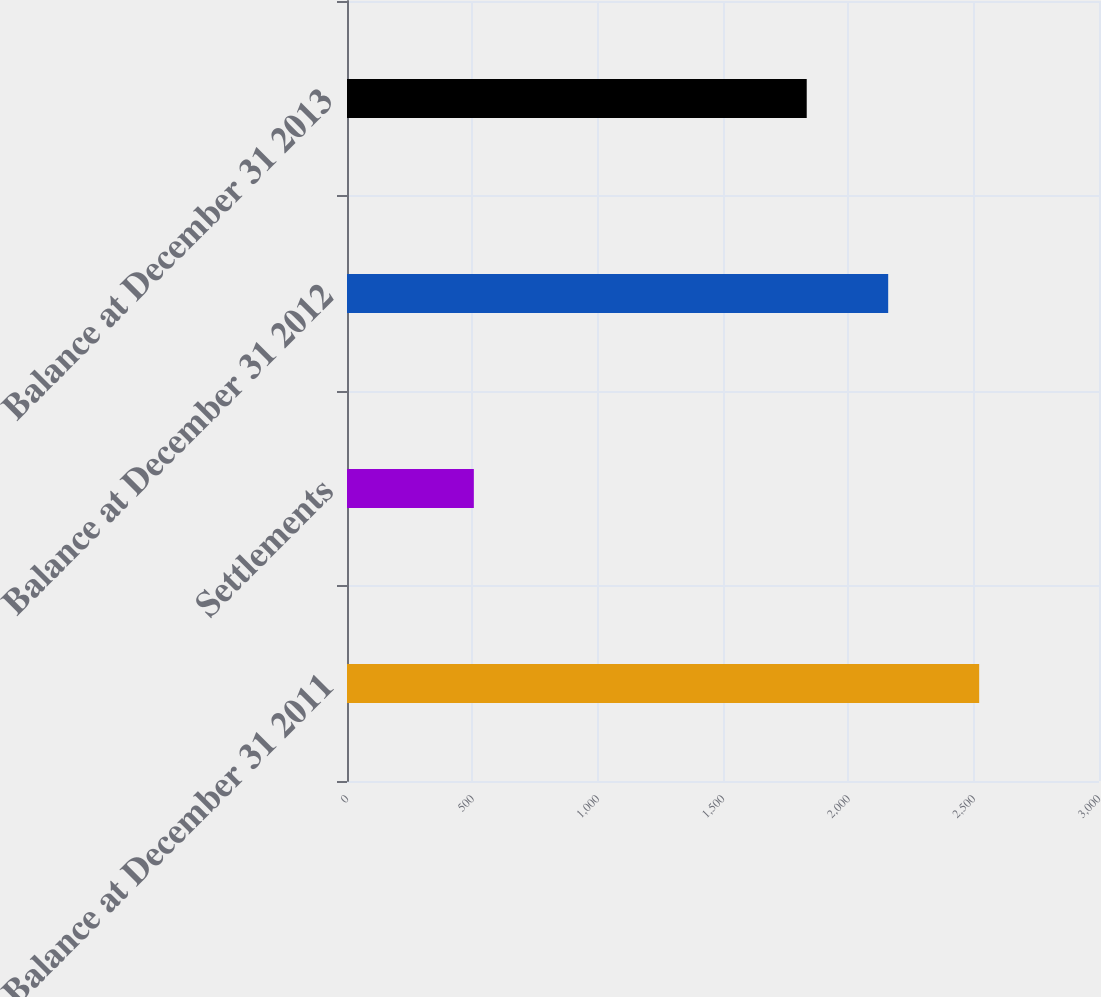Convert chart to OTSL. <chart><loc_0><loc_0><loc_500><loc_500><bar_chart><fcel>Balance at December 31 2011<fcel>Settlements<fcel>Balance at December 31 2012<fcel>Balance at December 31 2013<nl><fcel>2522<fcel>506<fcel>2159<fcel>1834<nl></chart> 